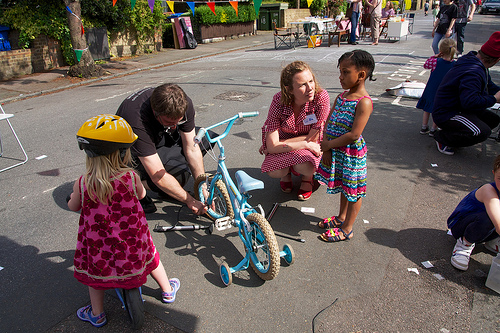<image>
Is the child on the bike? No. The child is not positioned on the bike. They may be near each other, but the child is not supported by or resting on top of the bike. Is there a bicycle in front of the helmet? No. The bicycle is not in front of the helmet. The spatial positioning shows a different relationship between these objects. 